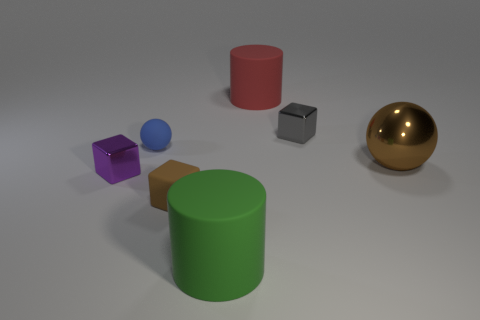Subtract all shiny cubes. How many cubes are left? 1 Add 2 blue things. How many objects exist? 9 Subtract all blocks. How many objects are left? 4 Subtract 1 cylinders. How many cylinders are left? 1 Subtract all yellow cylinders. Subtract all gray balls. How many cylinders are left? 2 Subtract all cyan spheres. How many blue cylinders are left? 0 Subtract all rubber things. Subtract all big green objects. How many objects are left? 2 Add 5 metal cubes. How many metal cubes are left? 7 Add 7 tiny cyan metal balls. How many tiny cyan metal balls exist? 7 Subtract all purple cubes. How many cubes are left? 2 